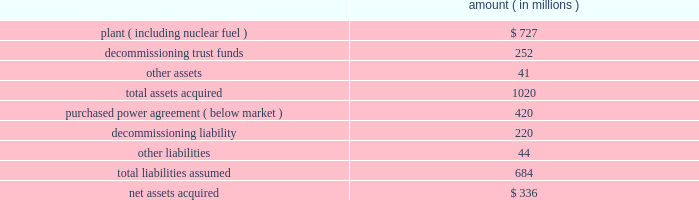Entergy corporation and subsidiaries notes to financial statements amount ( in millions ) .
Subsequent to the closing , entergy received approximately $ 6 million from consumers energy company as part of the post-closing adjustment defined in the asset sale agreement .
The post-closing adjustment amount resulted in an approximately $ 6 million reduction in plant and a corresponding reduction in other liabilities .
For the ppa , which was at below-market prices at the time of the acquisition , non-utility nuclear will amortize a liability to revenue over the life of the agreement .
The amount that will be amortized each period is based upon the difference between the present value calculated at the date of acquisition of each year's difference between revenue under the agreement and revenue based on estimated market prices .
Amounts amortized to revenue were $ 53 million in 2009 , $ 76 million in 2008 , and $ 50 million in 2007 .
The amounts to be amortized to revenue for the next five years will be $ 46 million for 2010 , $ 43 million for 2011 , $ 17 million in 2012 , $ 18 million for 2013 , and $ 16 million for 2014 .
Nypa value sharing agreements non-utility nuclear's purchase of the fitzpatrick and indian point 3 plants from nypa included value sharing agreements with nypa .
In october 2007 , non-utility nuclear and nypa amended and restated the value sharing agreements to clarify and amend certain provisions of the original terms .
Under the amended value sharing agreements , non-utility nuclear will make annual payments to nypa based on the generation output of the indian point 3 and fitzpatrick plants from january 2007 through december 2014 .
Non-utility nuclear will pay nypa $ 6.59 per mwh for power sold from indian point 3 , up to an annual cap of $ 48 million , and $ 3.91 per mwh for power sold from fitzpatrick , up to an annual cap of $ 24 million .
The annual payment for each year's output is due by january 15 of the following year .
Non-utility nuclear will record its liability for payments to nypa as power is generated and sold by indian point 3 and fitzpatrick .
An amount equal to the liability will be recorded to the plant asset account as contingent purchase price consideration for the plants .
In 2009 , 2008 , and 2007 , non-utility nuclear recorded $ 72 million as plant for generation during each of those years .
This amount will be depreciated over the expected remaining useful life of the plants .
In august 2008 , non-utility nuclear entered into a resolution of a dispute with nypa over the applicability of the value sharing agreements to its fitzpatrick and indian point 3 nuclear power plants after the planned spin-off of the non-utility nuclear business .
Under the resolution , non-utility nuclear agreed not to treat the separation as a "cessation event" that would terminate its obligation to make the payments under the value sharing agreements .
As a result , after the spin-off transaction , enexus will continue to be obligated to make payments to nypa under the amended and restated value sharing agreements. .
What was the average amounts amortized to revenue from 2010to 2014? 
Computations: (((16 + (18 + (17 + (46 + 46)))) + 5) / 2)
Answer: 74.0. 